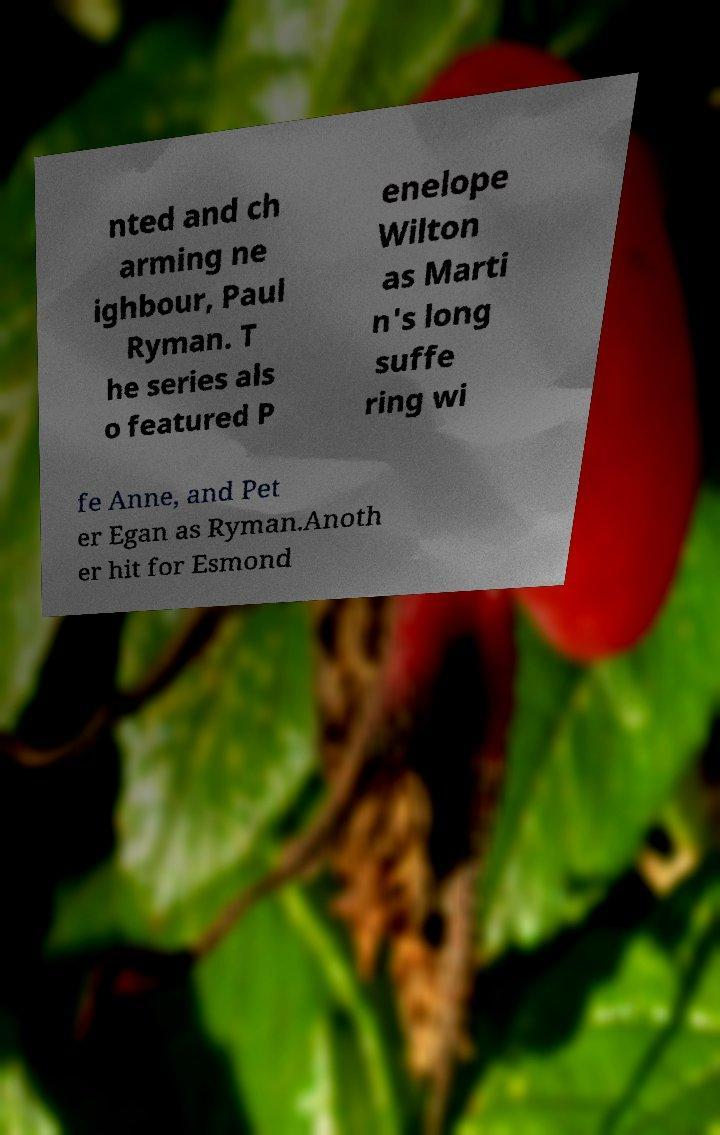Can you read and provide the text displayed in the image?This photo seems to have some interesting text. Can you extract and type it out for me? nted and ch arming ne ighbour, Paul Ryman. T he series als o featured P enelope Wilton as Marti n's long suffe ring wi fe Anne, and Pet er Egan as Ryman.Anoth er hit for Esmond 